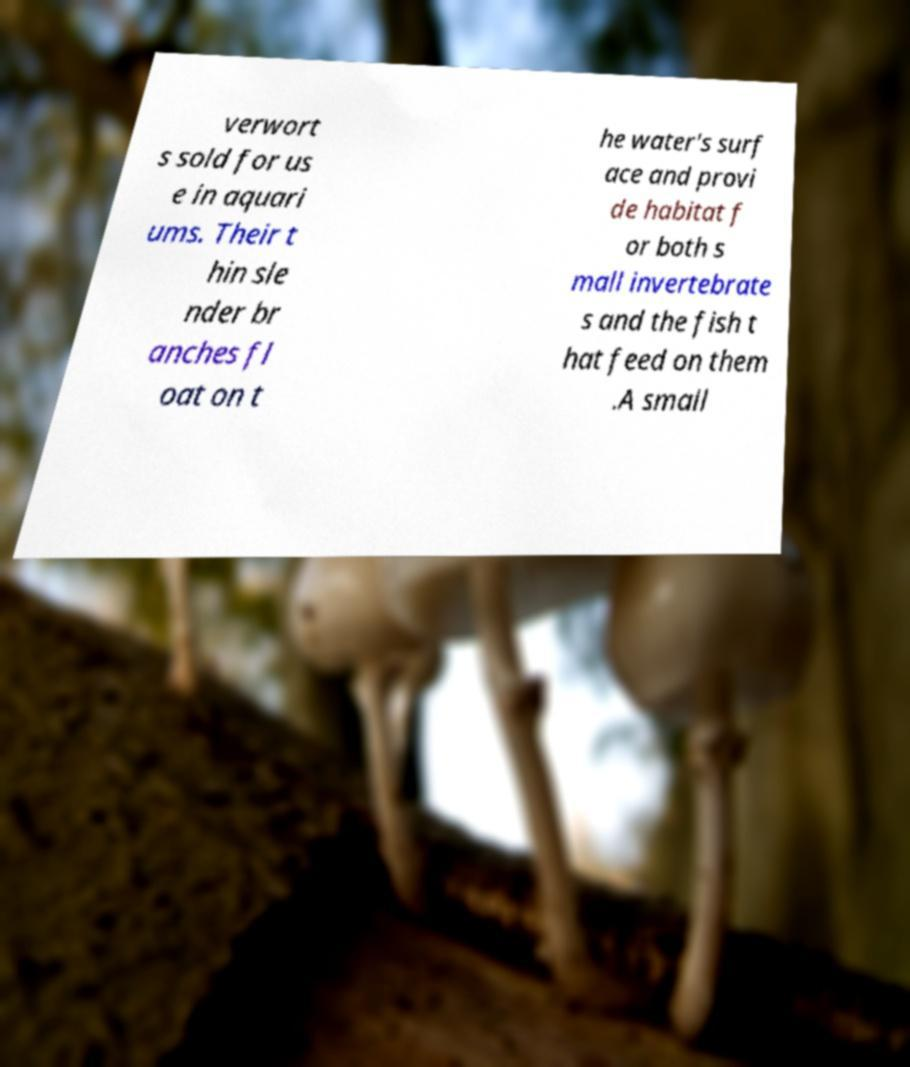For documentation purposes, I need the text within this image transcribed. Could you provide that? verwort s sold for us e in aquari ums. Their t hin sle nder br anches fl oat on t he water's surf ace and provi de habitat f or both s mall invertebrate s and the fish t hat feed on them .A small 